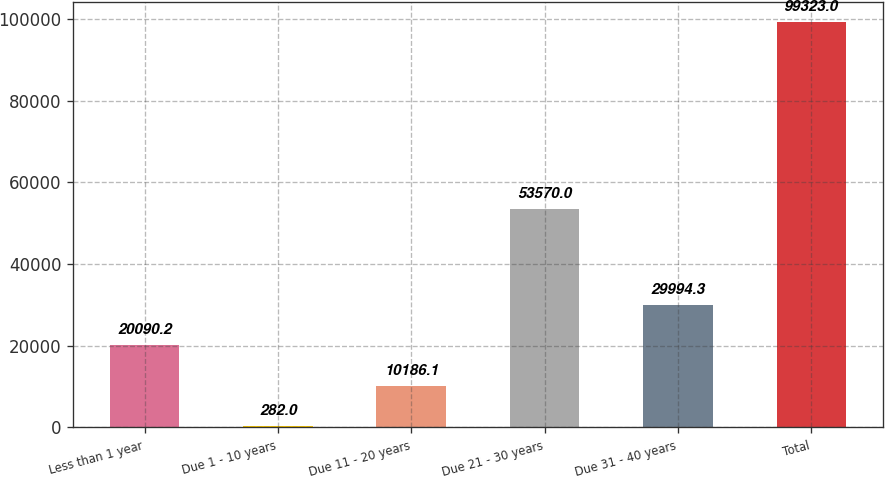<chart> <loc_0><loc_0><loc_500><loc_500><bar_chart><fcel>Less than 1 year<fcel>Due 1 - 10 years<fcel>Due 11 - 20 years<fcel>Due 21 - 30 years<fcel>Due 31 - 40 years<fcel>Total<nl><fcel>20090.2<fcel>282<fcel>10186.1<fcel>53570<fcel>29994.3<fcel>99323<nl></chart> 